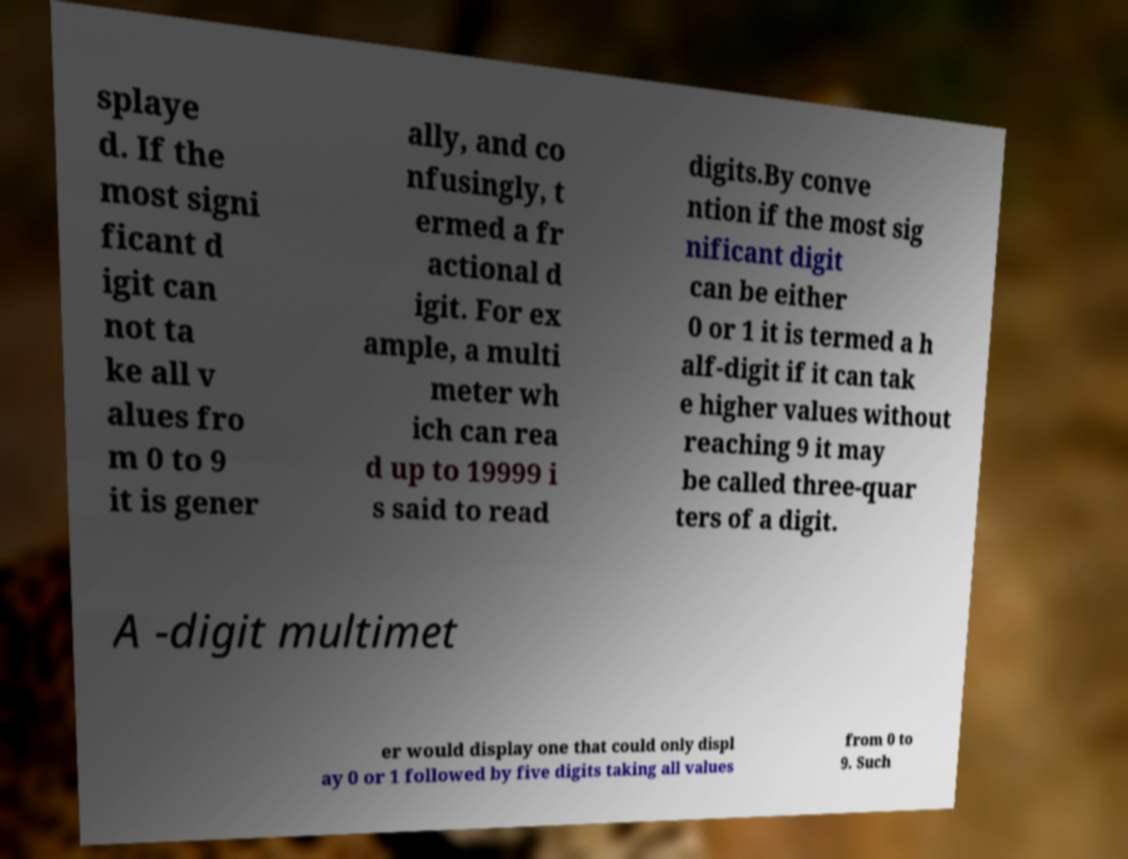Please identify and transcribe the text found in this image. splaye d. If the most signi ficant d igit can not ta ke all v alues fro m 0 to 9 it is gener ally, and co nfusingly, t ermed a fr actional d igit. For ex ample, a multi meter wh ich can rea d up to 19999 i s said to read digits.By conve ntion if the most sig nificant digit can be either 0 or 1 it is termed a h alf-digit if it can tak e higher values without reaching 9 it may be called three-quar ters of a digit. A -digit multimet er would display one that could only displ ay 0 or 1 followed by five digits taking all values from 0 to 9. Such 